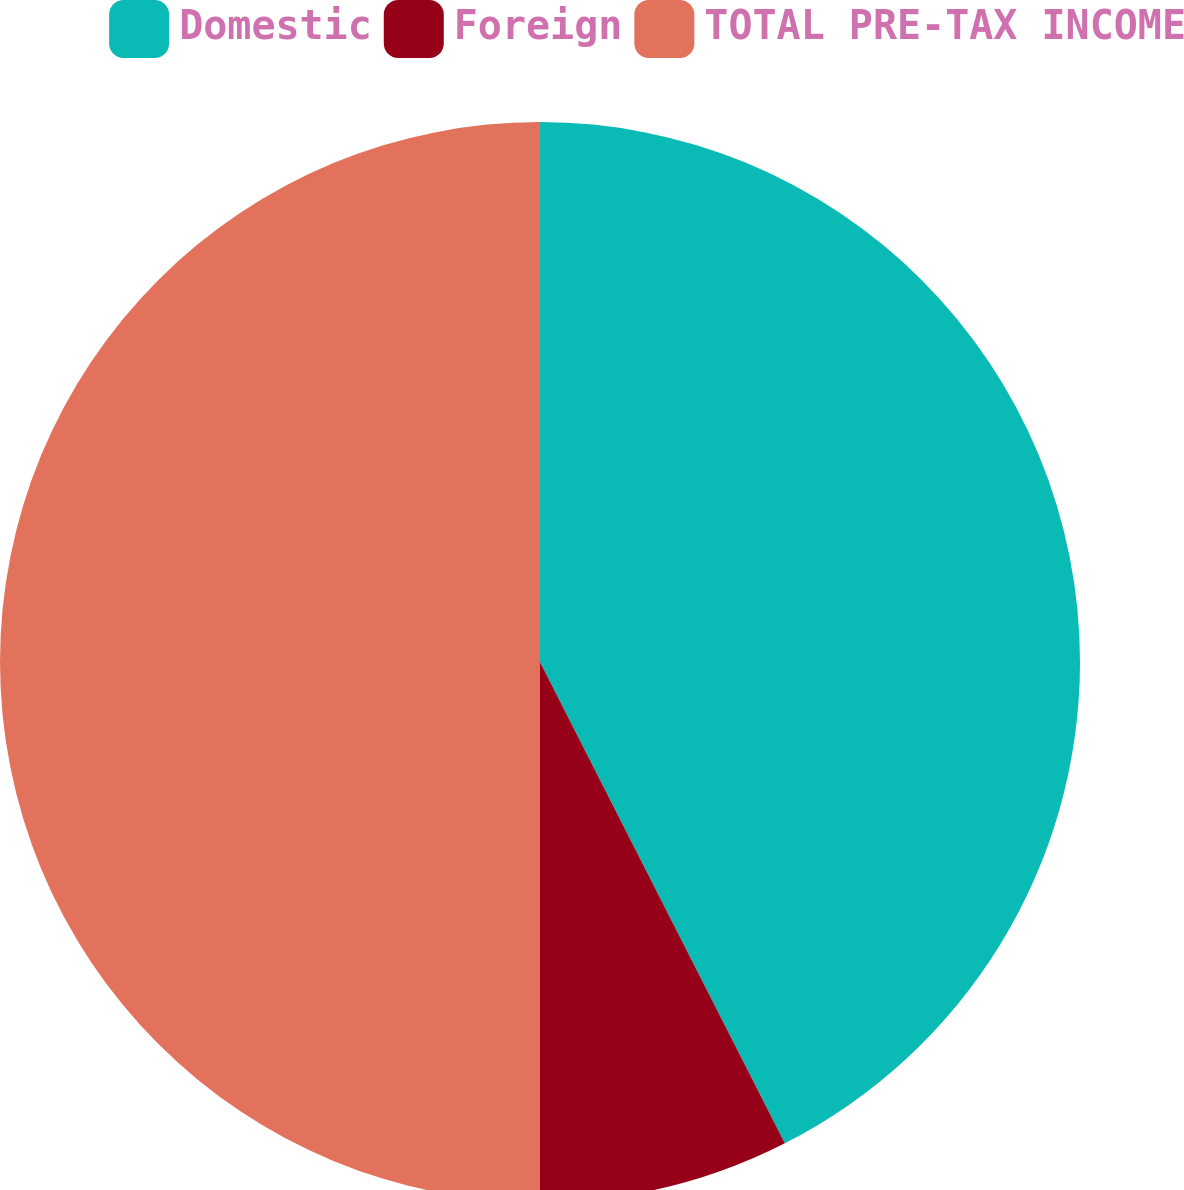Convert chart to OTSL. <chart><loc_0><loc_0><loc_500><loc_500><pie_chart><fcel>Domestic<fcel>Foreign<fcel>TOTAL PRE-TAX INCOME<nl><fcel>42.51%<fcel>7.49%<fcel>50.0%<nl></chart> 